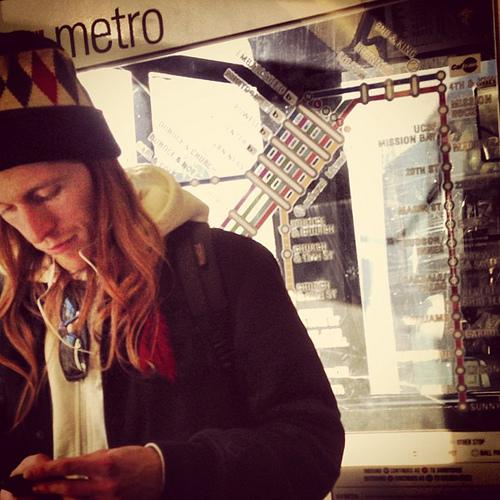Question: what does the person have hanging from the front of their sweatshirt?
Choices:
A. Sunglasses.
B. Money pouch.
C. Lanyard.
D. Jump drive on a necklace.
Answer with the letter. Answer: A Question: how many people are shown?
Choices:
A. One.
B. Two.
C. Three.
D. Four.
Answer with the letter. Answer: A Question: when was the photo taken?
Choices:
A. Night time.
B. Daytime.
C. Afternoon.
D. Morning.
Answer with the letter. Answer: B Question: what is the gender of the person?
Choices:
A. Female.
B. Transgender.
C. Male.
D. Shemale.
Answer with the letter. Answer: C Question: how many letters are shown on the map behind the person?
Choices:
A. Four.
B. Five.
C. Three.
D. Six.
Answer with the letter. Answer: B 